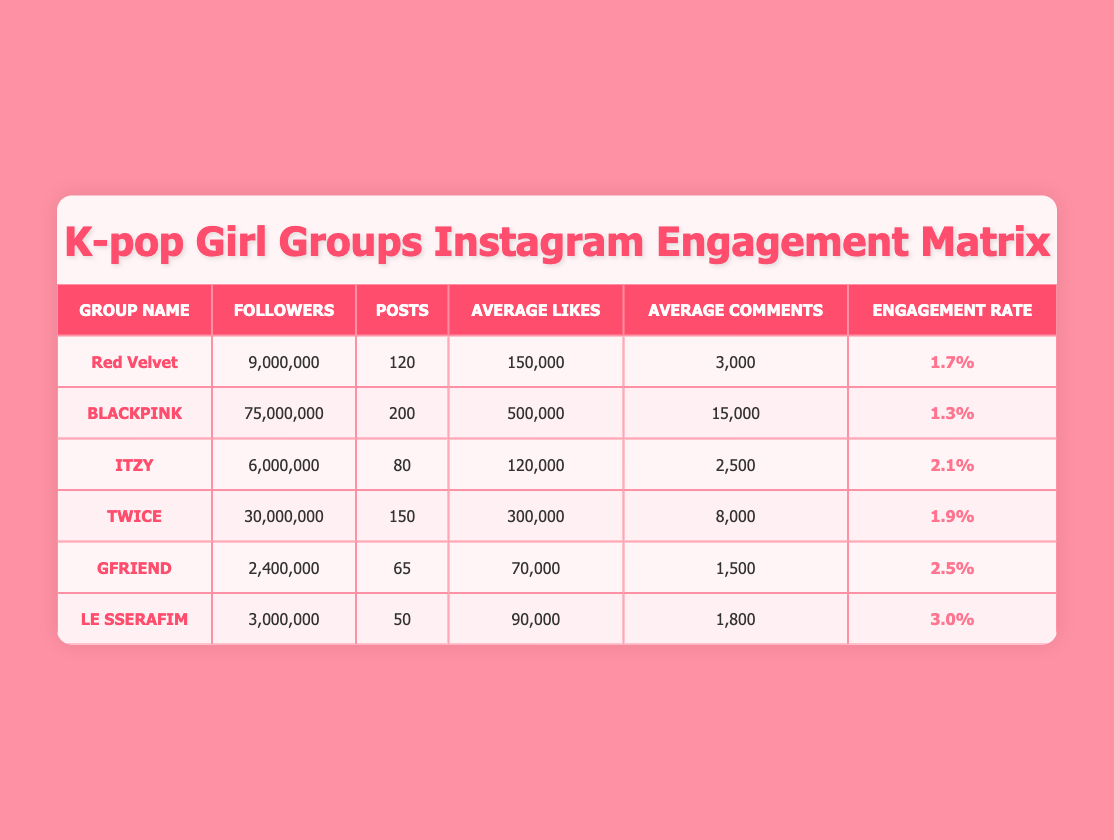What is the engagement rate of Red Velvet? Red Velvet's engagement rate is listed directly in the table under the "Engagement Rate" column, which shows 1.7%.
Answer: 1.7% Which group has the highest average likes per post? By comparing the "Average Likes" column across all groups, BLACKPINK has the highest value at 500,000 likes.
Answer: BLACKPINK What is the total number of followers for all groups combined? To find the total, add all followers: 9,000,000 (Red Velvet) + 75,000,000 (BLACKPINK) + 6,000,000 (ITZY) + 30,000,000 (TWICE) + 2,400,000 (GFRIEND) + 3,000,000 (LE SSERAFIM) = 125,400,000.
Answer: 125,400,000 Is ITZY's engagement rate higher than TWICE's? ITZY's engagement rate is 2.1%, while TWICE's is 1.9%. Since 2.1% is greater than 1.9%, the statement is true.
Answer: Yes Which group has the smallest number of posts, and what is that number? By reviewing the "Posts" column, GFRIEND has the smallest number of posts with 65.
Answer: 65 What is the average engagement rate of all K-pop girl groups in the table? To find the average, sum the engagement rates: 1.7 + 1.3 + 2.1 + 1.9 + 2.5 + 3 = 12.5. Then divide by the number of groups (6): 12.5 / 6 = 2.08.
Answer: 2.08 Does LE SSERAFIM have more average comments than GFRIEND? LE SSERAFIM has 1,800 average comments while GFRIEND has 1,500. Since 1,800 is greater than 1,500, the statement is true.
Answer: Yes What percentage of the total posts does BLACKPINK make compared to all groups? BLACKPINK has 200 posts. The total number of posts is 120 (Red Velvet) + 200 (BLACKPINK) + 80 (ITZY) + 150 (TWICE) + 65 (GFRIEND) + 50 (LE SSERAFIM) = 665. Calculate the percentage: (200 / 665) * 100 = 30.15%, approximately.
Answer: 30.15% 